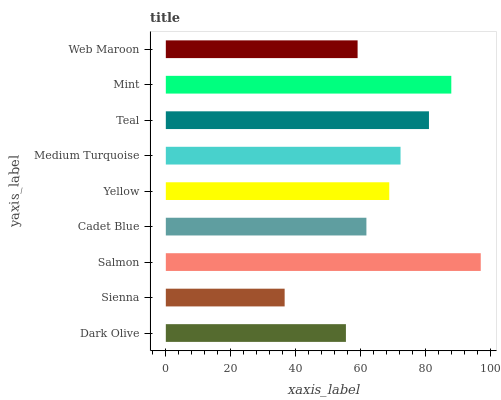Is Sienna the minimum?
Answer yes or no. Yes. Is Salmon the maximum?
Answer yes or no. Yes. Is Salmon the minimum?
Answer yes or no. No. Is Sienna the maximum?
Answer yes or no. No. Is Salmon greater than Sienna?
Answer yes or no. Yes. Is Sienna less than Salmon?
Answer yes or no. Yes. Is Sienna greater than Salmon?
Answer yes or no. No. Is Salmon less than Sienna?
Answer yes or no. No. Is Yellow the high median?
Answer yes or no. Yes. Is Yellow the low median?
Answer yes or no. Yes. Is Teal the high median?
Answer yes or no. No. Is Cadet Blue the low median?
Answer yes or no. No. 